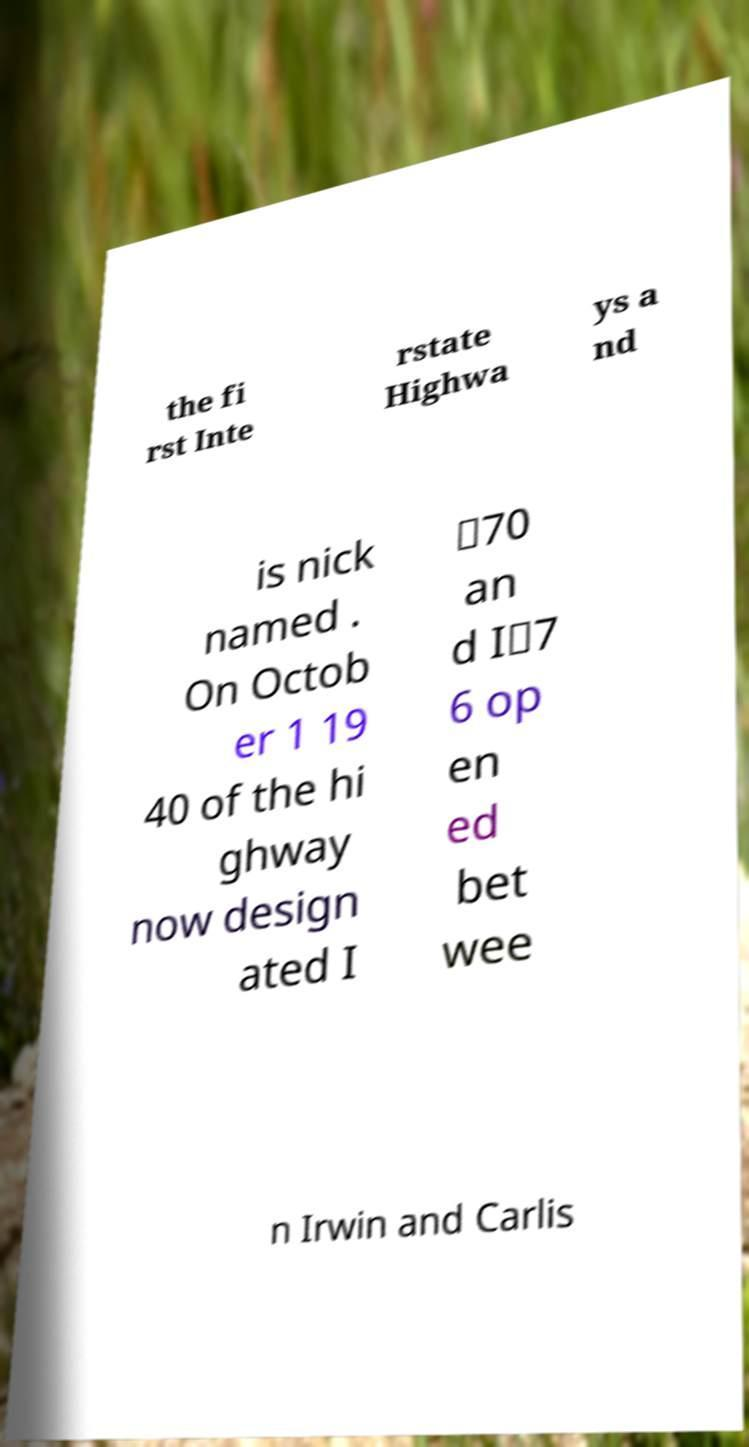I need the written content from this picture converted into text. Can you do that? the fi rst Inte rstate Highwa ys a nd is nick named . On Octob er 1 19 40 of the hi ghway now design ated I ‑70 an d I‑7 6 op en ed bet wee n Irwin and Carlis 